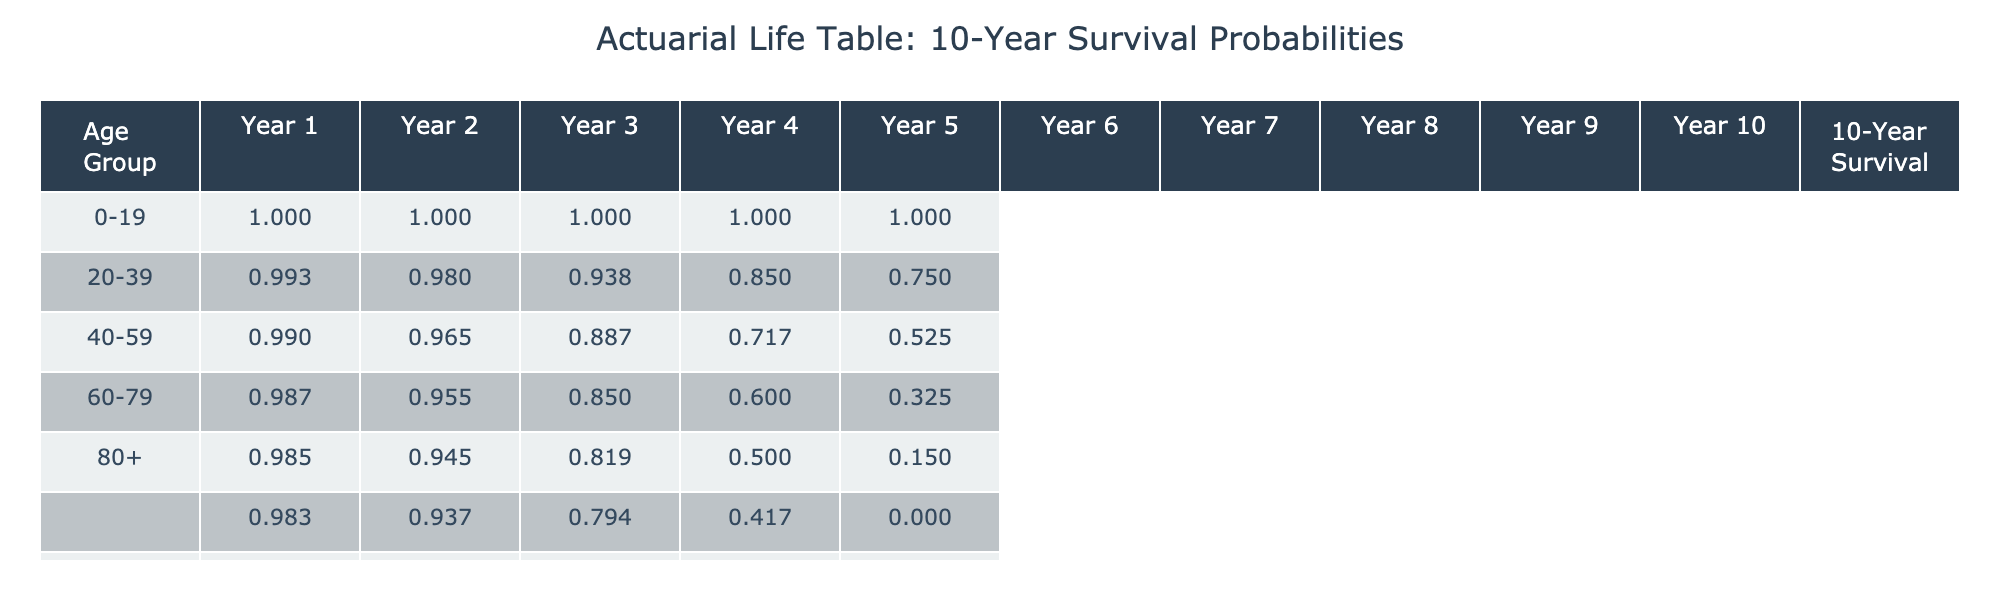What is the survival probability for the age group 40-59 after 10 years? The survival probability after 10 years for the age group 40-59 is provided in the table under the '10-Year Survival' column. For this age group, the value is 0.45.
Answer: 0.45 How many deaths occurred in the first year for the age group 60-79? The table shows the number of deaths for each year listed in the respective columns. For the age group 60-79, the number of deaths in the first year is specified as 90.
Answer: 90 What is the average survival probability across all age groups after 10 years? To calculate the average, add the survival probabilities for each age group (0.93 + 0.72 + 0.45 + 0.33 + 0.25 = 2.68) and divide by the number of age groups (5). The average survival probability is 2.68 / 5 = 0.536.
Answer: 0.536 Did the 80+ age group have a higher or lower survival probability compared to the 60-79 age group? The survival probability for the 80+ age group is 0.25, while for the 60-79 age group it is 0.33. Since 0.25 is less than 0.33, the 80+ group has a lower survival probability compared to the 60-79 group.
Answer: Lower What is the total number of deaths for the age group 20-39 over the 10-year period? The total number of deaths can be found by summing the deaths from Year 1 to Year 10 for the age group 20-39. The values are (20 + 15 + 10 + 10 + 8 + 6 + 5 + 4 + 5 + 3 = 86). Thus, the total number of deaths is 86.
Answer: 86 Which age group has the highest survival probability after 10 years? Reviewing the '10-Year Survival' column, the age group 0-19 has the highest survival probability of 0.93, compared to other groups.
Answer: 0-19 What is the difference in survival probability between the age groups 0-19 and 60-79? The survival probability for the age group 0-19 is 0.93, and for 60-79 it is 0.33. The difference is calculated as (0.93 - 0.33 = 0.60).
Answer: 0.60 Are there any age groups with a survival probability below 0.4? By reviewing the '10-Year Survival' column, the age groups 40-59 (0.45), 60-79 (0.33), and 80+ (0.25) show that both 60-79 and 80+ are below 0.4, confirming the existence of age groups with a survival probability below this threshold.
Answer: Yes What was the trend in deaths for the age group 40-59 from Year 1 to Year 10? In the age group 40-59, the death count decreases each year, with the values being 50, 40, 30, 25, 20, 18, 15, 12, 15, and 10. This indicates a downward trend in the number of deaths over the 10-year period.
Answer: Downward trend 